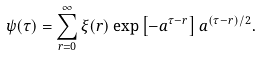Convert formula to latex. <formula><loc_0><loc_0><loc_500><loc_500>\psi ( \tau ) = \sum _ { r = 0 } ^ { \infty } \xi ( r ) \exp \left [ - a ^ { \tau - r } \right ] a ^ { ( \tau - r ) / 2 } .</formula> 